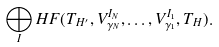<formula> <loc_0><loc_0><loc_500><loc_500>\bigoplus _ { I } H F ( T _ { H ^ { \prime } } , V _ { \gamma _ { N } } ^ { I _ { N } } , \dots , V _ { \gamma _ { 1 } } ^ { I _ { 1 } } , T _ { H } ) .</formula> 